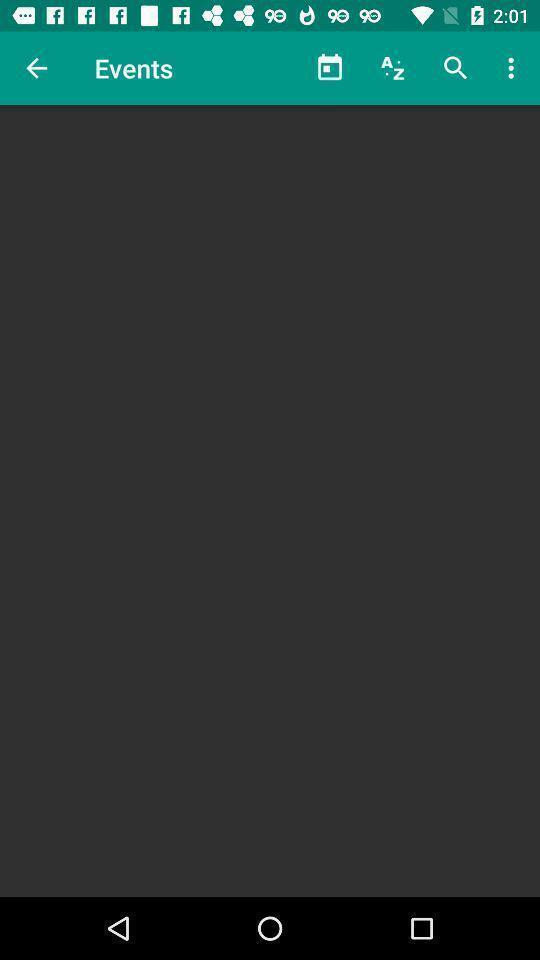What is the overall content of this screenshot? Screen showing events page in the app. 